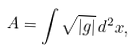Convert formula to latex. <formula><loc_0><loc_0><loc_500><loc_500>A = \int \sqrt { | g | } \, d ^ { 2 } x ,</formula> 